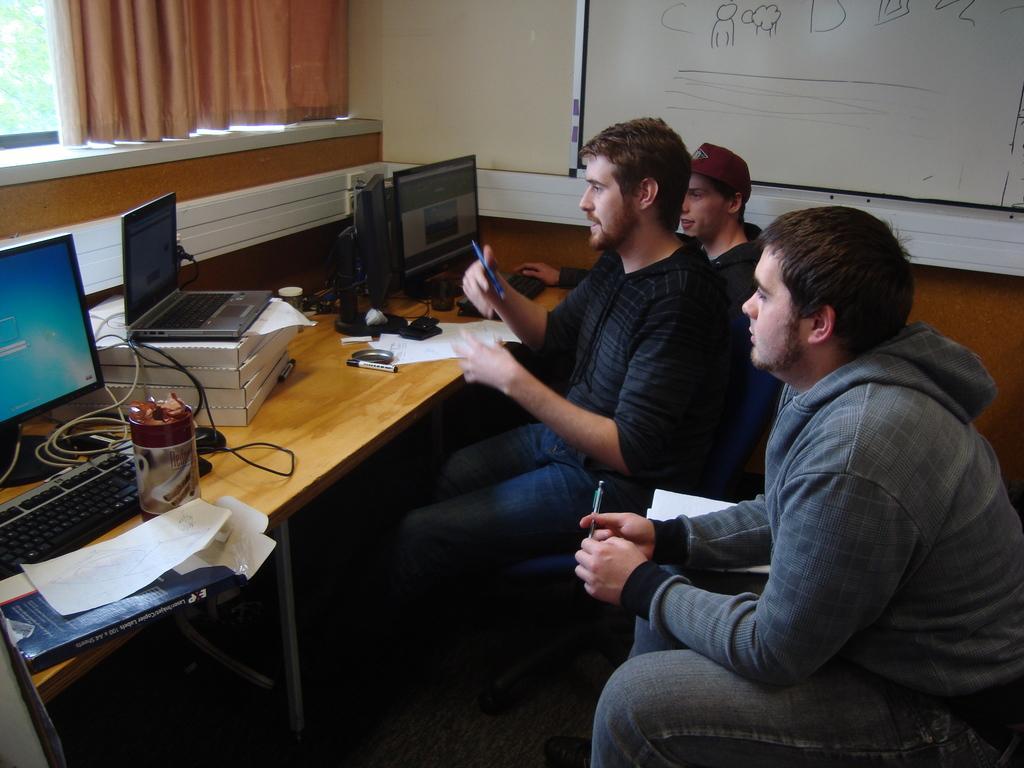How would you summarize this image in a sentence or two? In this picture we can see three persons are sitting on the chairs. This is table. On the table there are monitors, keyboard, and mouse. This is laptop. On the background there is a wall and this is curtain. 